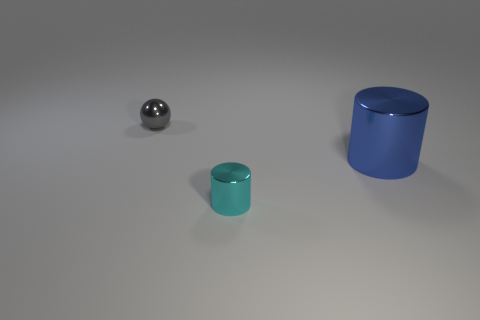Are the objects arranged in a particular pattern? The objects are arranged in a roughly diagonal line across the image, with varying sizes suggesting depth. 